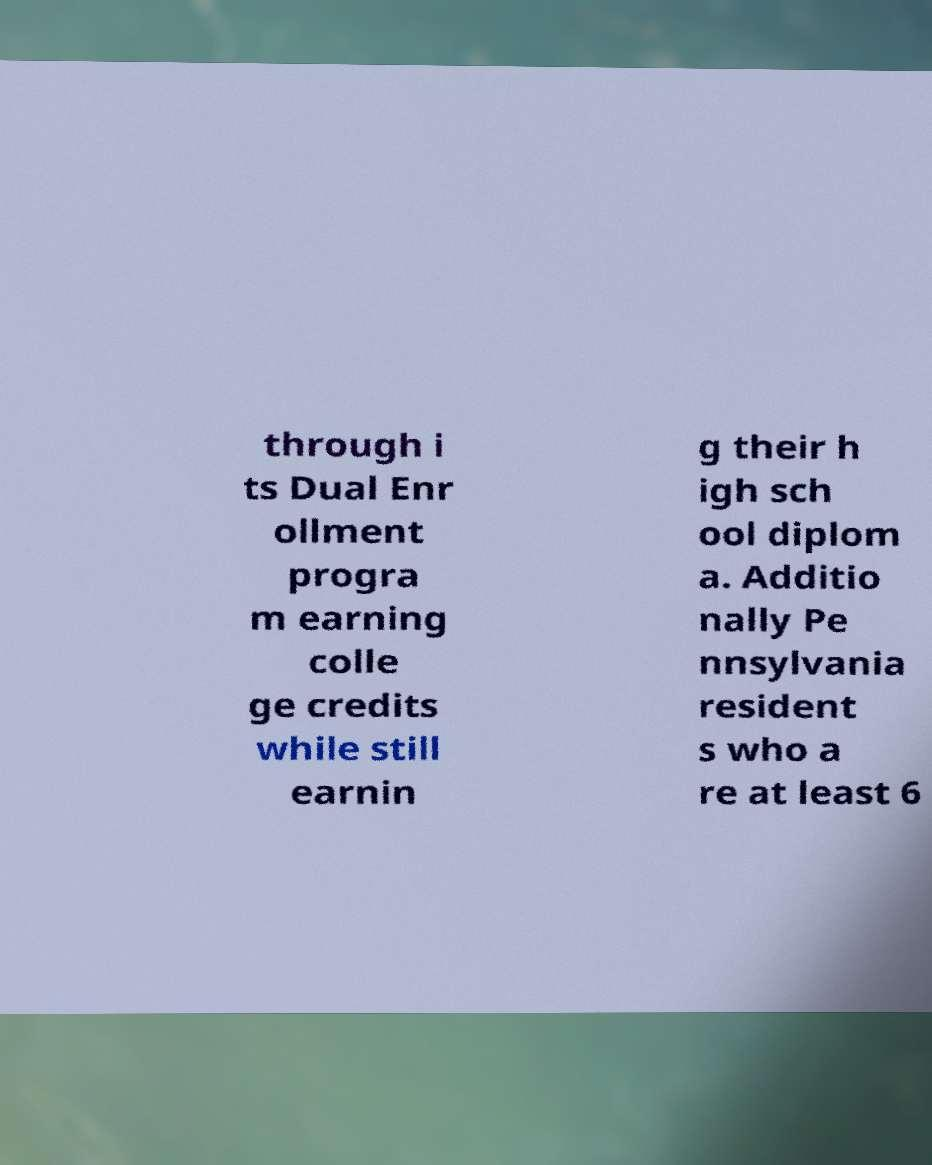Please read and relay the text visible in this image. What does it say? through i ts Dual Enr ollment progra m earning colle ge credits while still earnin g their h igh sch ool diplom a. Additio nally Pe nnsylvania resident s who a re at least 6 